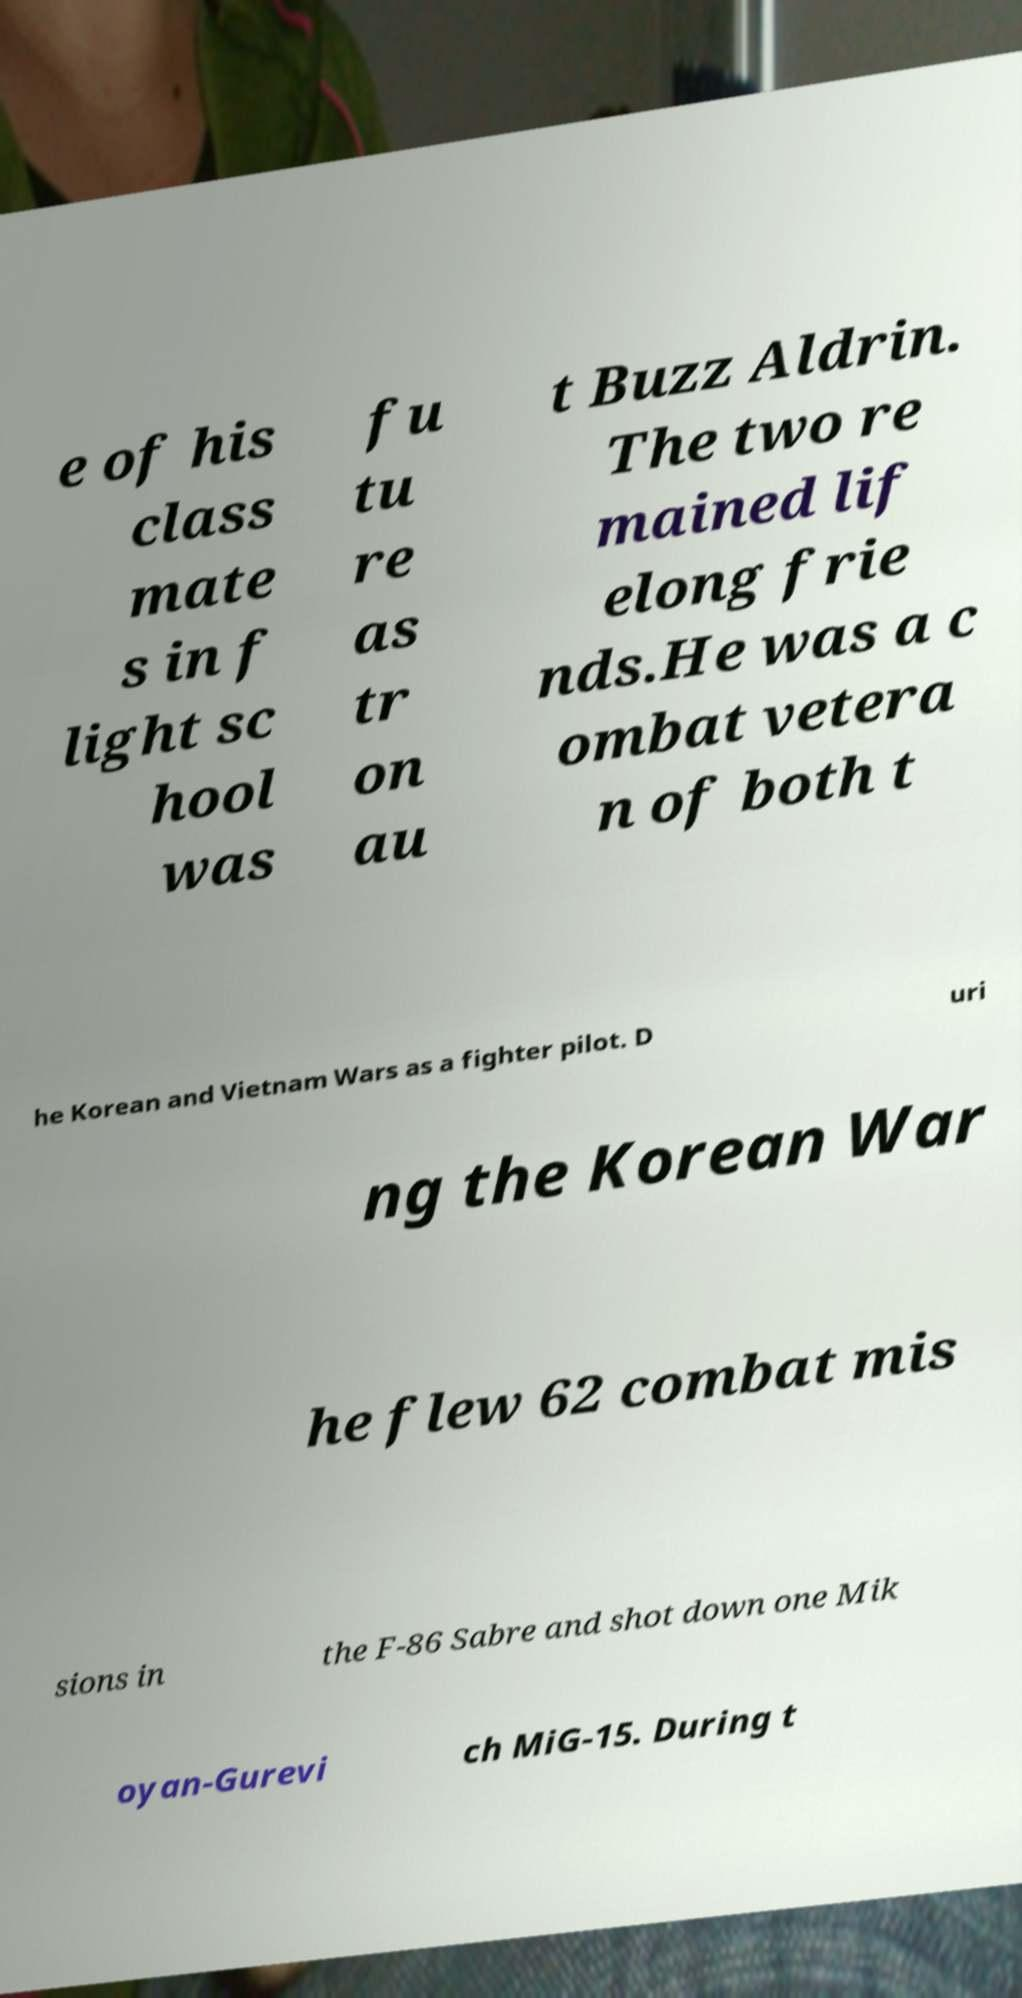Can you accurately transcribe the text from the provided image for me? e of his class mate s in f light sc hool was fu tu re as tr on au t Buzz Aldrin. The two re mained lif elong frie nds.He was a c ombat vetera n of both t he Korean and Vietnam Wars as a fighter pilot. D uri ng the Korean War he flew 62 combat mis sions in the F-86 Sabre and shot down one Mik oyan-Gurevi ch MiG-15. During t 